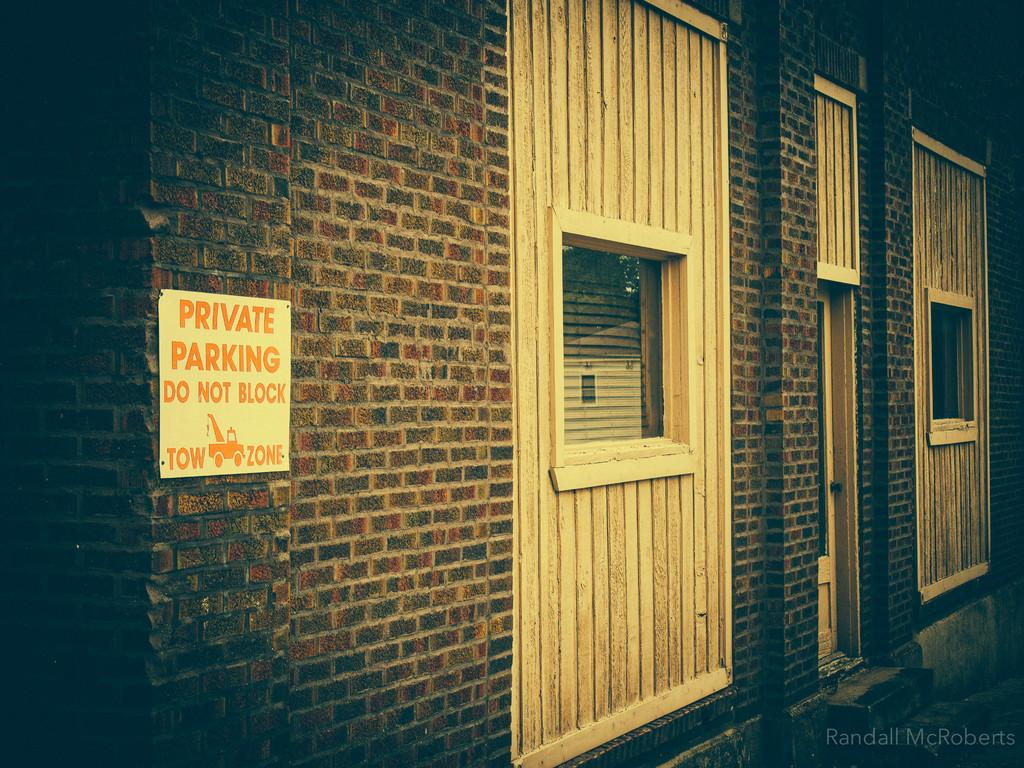What type of structure is visible in the image? There is a building in the image. What features can be seen on the building? The building has windows and a door. Is there any additional information about the interior of the building? Yes, there is a board pinned to a wall in the building. What type of current can be seen flowing through the building in the image? There is no current visible in the image, as it features a building with windows, a door, and a board pinned to a wall. 